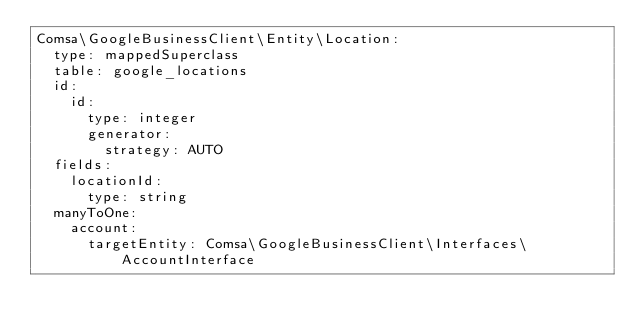Convert code to text. <code><loc_0><loc_0><loc_500><loc_500><_YAML_>Comsa\GoogleBusinessClient\Entity\Location:
  type: mappedSuperclass
  table: google_locations
  id:
    id:
      type: integer
      generator:
        strategy: AUTO
  fields:
    locationId:
      type: string
  manyToOne:
    account:
      targetEntity: Comsa\GoogleBusinessClient\Interfaces\AccountInterface
</code> 